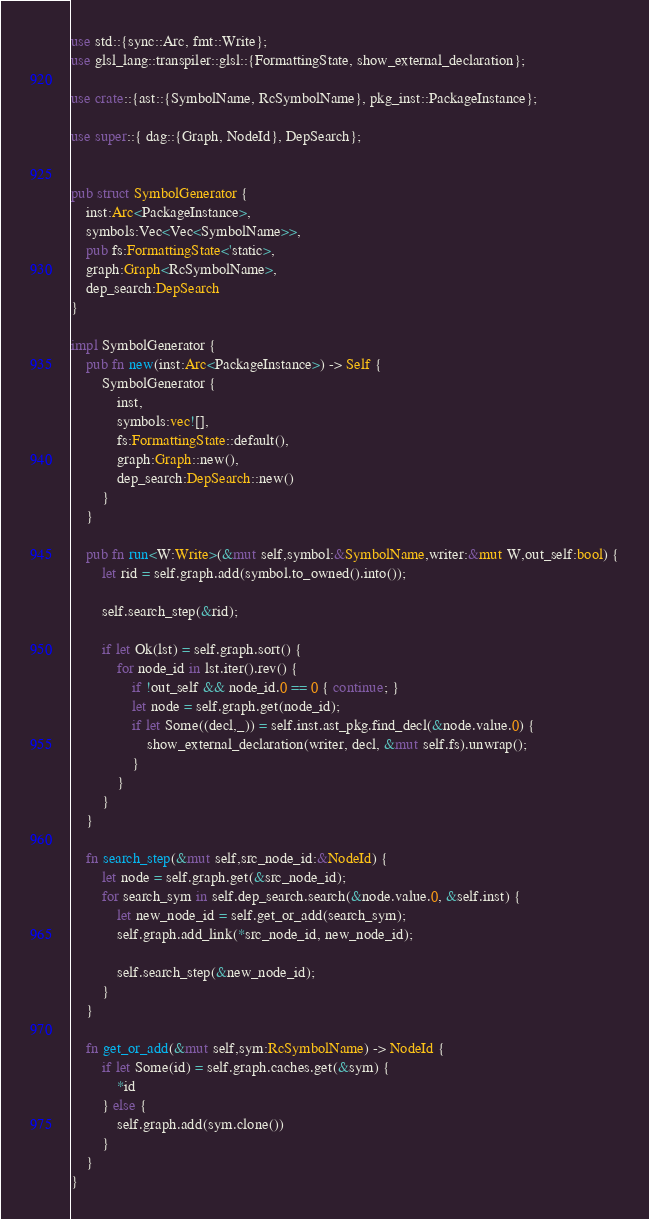Convert code to text. <code><loc_0><loc_0><loc_500><loc_500><_Rust_>use std::{sync::Arc, fmt::Write};
use glsl_lang::transpiler::glsl::{FormattingState, show_external_declaration};

use crate::{ast::{SymbolName, RcSymbolName}, pkg_inst::PackageInstance};

use super::{ dag::{Graph, NodeId}, DepSearch};


pub struct SymbolGenerator {
    inst:Arc<PackageInstance>,
    symbols:Vec<Vec<SymbolName>>,
    pub fs:FormattingState<'static>,
    graph:Graph<RcSymbolName>, 
    dep_search:DepSearch
}

impl SymbolGenerator {
    pub fn new(inst:Arc<PackageInstance>) -> Self {
        SymbolGenerator { 
            inst,
            symbols:vec![],
            fs:FormattingState::default(),
            graph:Graph::new(),
            dep_search:DepSearch::new() 
        }
    }

    pub fn run<W:Write>(&mut self,symbol:&SymbolName,writer:&mut W,out_self:bool) {
        let rid = self.graph.add(symbol.to_owned().into());
       
        self.search_step(&rid);

        if let Ok(lst) = self.graph.sort() {
            for node_id in lst.iter().rev() {
                if !out_self && node_id.0 == 0 { continue; }
                let node = self.graph.get(node_id);
                if let Some((decl,_)) = self.inst.ast_pkg.find_decl(&node.value.0) {
                    show_external_declaration(writer, decl, &mut self.fs).unwrap();
                }
            }
        }
    }

    fn search_step(&mut self,src_node_id:&NodeId) {
        let node = self.graph.get(&src_node_id);
        for search_sym in self.dep_search.search(&node.value.0, &self.inst) {
            let new_node_id = self.get_or_add(search_sym);
            self.graph.add_link(*src_node_id, new_node_id);

            self.search_step(&new_node_id);
        }
    }

    fn get_or_add(&mut self,sym:RcSymbolName) -> NodeId {
        if let Some(id) = self.graph.caches.get(&sym) {
            *id
        } else {
            self.graph.add(sym.clone())
        }
    }
}</code> 